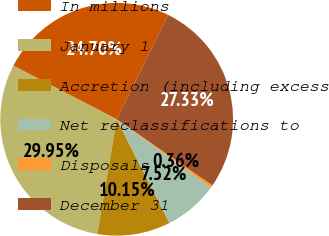Convert chart. <chart><loc_0><loc_0><loc_500><loc_500><pie_chart><fcel>In millions<fcel>January 1<fcel>Accretion (including excess<fcel>Net reclassifications to<fcel>Disposals<fcel>December 31<nl><fcel>24.7%<fcel>29.95%<fcel>10.15%<fcel>7.52%<fcel>0.36%<fcel>27.33%<nl></chart> 